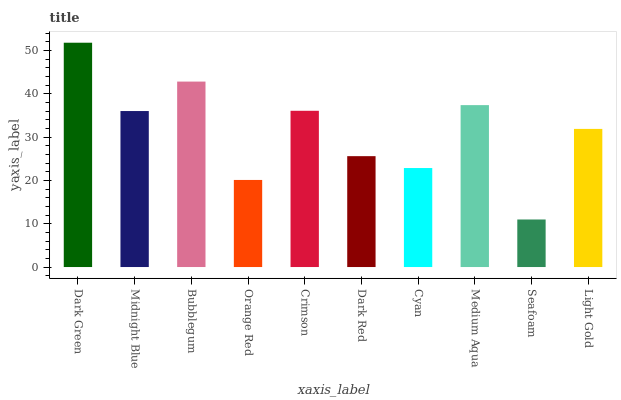Is Seafoam the minimum?
Answer yes or no. Yes. Is Dark Green the maximum?
Answer yes or no. Yes. Is Midnight Blue the minimum?
Answer yes or no. No. Is Midnight Blue the maximum?
Answer yes or no. No. Is Dark Green greater than Midnight Blue?
Answer yes or no. Yes. Is Midnight Blue less than Dark Green?
Answer yes or no. Yes. Is Midnight Blue greater than Dark Green?
Answer yes or no. No. Is Dark Green less than Midnight Blue?
Answer yes or no. No. Is Midnight Blue the high median?
Answer yes or no. Yes. Is Light Gold the low median?
Answer yes or no. Yes. Is Cyan the high median?
Answer yes or no. No. Is Midnight Blue the low median?
Answer yes or no. No. 